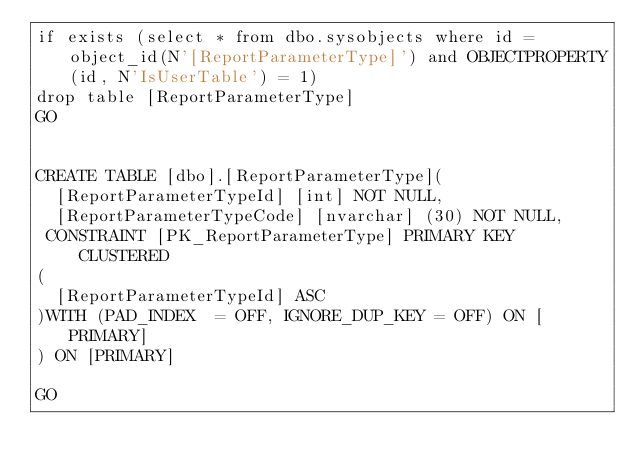Convert code to text. <code><loc_0><loc_0><loc_500><loc_500><_SQL_>if exists (select * from dbo.sysobjects where id = object_id(N'[ReportParameterType]') and OBJECTPROPERTY(id, N'IsUserTable') = 1)
drop table [ReportParameterType]
GO


CREATE TABLE [dbo].[ReportParameterType](
	[ReportParameterTypeId] [int] NOT NULL,
	[ReportParameterTypeCode] [nvarchar] (30) NOT NULL,
 CONSTRAINT [PK_ReportParameterType] PRIMARY KEY CLUSTERED 
(
	[ReportParameterTypeId] ASC
)WITH (PAD_INDEX  = OFF, IGNORE_DUP_KEY = OFF) ON [PRIMARY]
) ON [PRIMARY]

GO</code> 